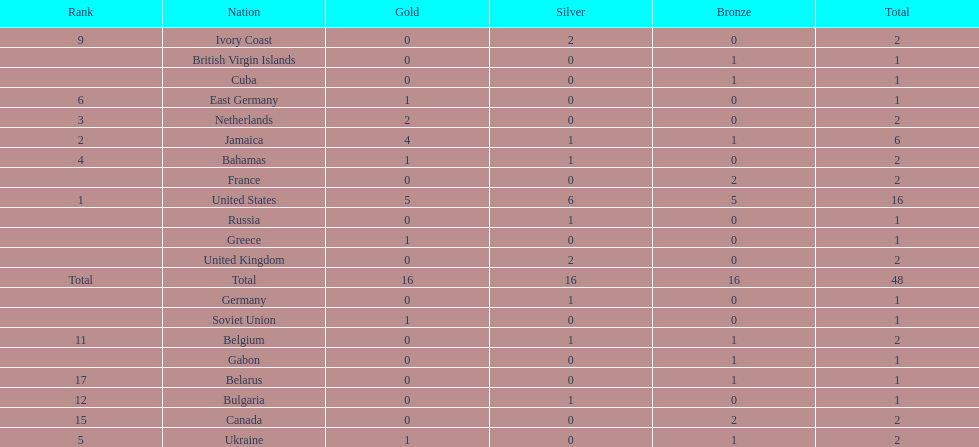How many nations received more medals than canada? 2. 